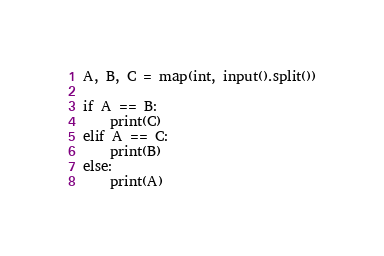Convert code to text. <code><loc_0><loc_0><loc_500><loc_500><_Python_>A, B, C = map(int, input().split())

if A == B:
    print(C)
elif A == C:
    print(B)
else:
    print(A)
</code> 